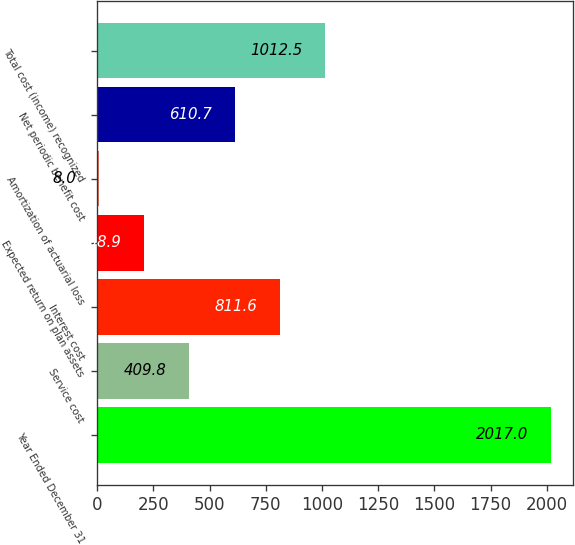Convert chart. <chart><loc_0><loc_0><loc_500><loc_500><bar_chart><fcel>Year Ended December 31<fcel>Service cost<fcel>Interest cost<fcel>Expected return on plan assets<fcel>Amortization of actuarial loss<fcel>Net periodic benefit cost<fcel>Total cost (income) recognized<nl><fcel>2017<fcel>409.8<fcel>811.6<fcel>208.9<fcel>8<fcel>610.7<fcel>1012.5<nl></chart> 